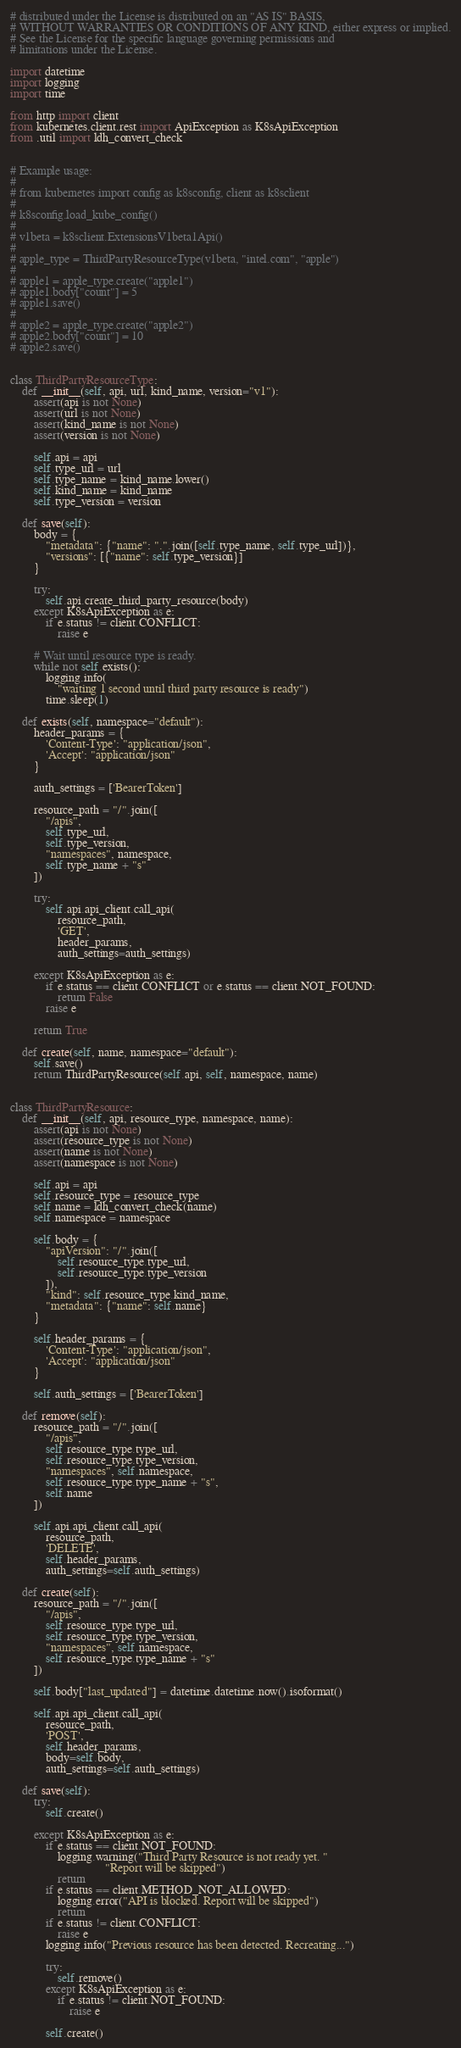Convert code to text. <code><loc_0><loc_0><loc_500><loc_500><_Python_># distributed under the License is distributed on an "AS IS" BASIS,
# WITHOUT WARRANTIES OR CONDITIONS OF ANY KIND, either express or implied.
# See the License for the specific language governing permissions and
# limitations under the License.

import datetime
import logging
import time

from http import client
from kubernetes.client.rest import ApiException as K8sApiException
from .util import ldh_convert_check


# Example usage:
#
# from kubernetes import config as k8sconfig, client as k8sclient
#
# k8sconfig.load_kube_config()
#
# v1beta = k8sclient.ExtensionsV1beta1Api()
#
# apple_type = ThirdPartyResourceType(v1beta, "intel.com", "apple")
#
# apple1 = apple_type.create("apple1")
# apple1.body["count"] = 5
# apple1.save()
#
# apple2 = apple_type.create("apple2")
# apple2.body["count"] = 10
# apple2.save()


class ThirdPartyResourceType:
    def __init__(self, api, url, kind_name, version="v1"):
        assert(api is not None)
        assert(url is not None)
        assert(kind_name is not None)
        assert(version is not None)

        self.api = api
        self.type_url = url
        self.type_name = kind_name.lower()
        self.kind_name = kind_name
        self.type_version = version

    def save(self):
        body = {
            "metadata": {"name": ".".join([self.type_name, self.type_url])},
            "versions": [{"name": self.type_version}]
        }

        try:
            self.api.create_third_party_resource(body)
        except K8sApiException as e:
            if e.status != client.CONFLICT:
                raise e

        # Wait until resource type is ready.
        while not self.exists():
            logging.info(
                "waiting 1 second until third party resource is ready")
            time.sleep(1)

    def exists(self, namespace="default"):
        header_params = {
            'Content-Type': "application/json",
            'Accept': "application/json"
        }

        auth_settings = ['BearerToken']

        resource_path = "/".join([
            "/apis",
            self.type_url,
            self.type_version,
            "namespaces", namespace,
            self.type_name + "s"
        ])

        try:
            self.api.api_client.call_api(
                resource_path,
                'GET',
                header_params,
                auth_settings=auth_settings)

        except K8sApiException as e:
            if e.status == client.CONFLICT or e.status == client.NOT_FOUND:
                return False
            raise e

        return True

    def create(self, name, namespace="default"):
        self.save()
        return ThirdPartyResource(self.api, self, namespace, name)


class ThirdPartyResource:
    def __init__(self, api, resource_type, namespace, name):
        assert(api is not None)
        assert(resource_type is not None)
        assert(name is not None)
        assert(namespace is not None)

        self.api = api
        self.resource_type = resource_type
        self.name = ldh_convert_check(name)
        self.namespace = namespace

        self.body = {
            "apiVersion": "/".join([
                self.resource_type.type_url,
                self.resource_type.type_version
            ]),
            "kind": self.resource_type.kind_name,
            "metadata": {"name": self.name}
        }

        self.header_params = {
            'Content-Type': "application/json",
            'Accept': "application/json"
        }

        self.auth_settings = ['BearerToken']

    def remove(self):
        resource_path = "/".join([
            "/apis",
            self.resource_type.type_url,
            self.resource_type.type_version,
            "namespaces", self.namespace,
            self.resource_type.type_name + "s",
            self.name
        ])

        self.api.api_client.call_api(
            resource_path,
            'DELETE',
            self.header_params,
            auth_settings=self.auth_settings)

    def create(self):
        resource_path = "/".join([
            "/apis",
            self.resource_type.type_url,
            self.resource_type.type_version,
            "namespaces", self.namespace,
            self.resource_type.type_name + "s"
        ])

        self.body["last_updated"] = datetime.datetime.now().isoformat()

        self.api.api_client.call_api(
            resource_path,
            'POST',
            self.header_params,
            body=self.body,
            auth_settings=self.auth_settings)

    def save(self):
        try:
            self.create()

        except K8sApiException as e:
            if e.status == client.NOT_FOUND:
                logging.warning("Third Party Resource is not ready yet. "
                                "Report will be skipped")
                return
            if e.status == client.METHOD_NOT_ALLOWED:
                logging.error("API is blocked. Report will be skipped")
                return
            if e.status != client.CONFLICT:
                raise e
            logging.info("Previous resource has been detected. Recreating...")

            try:
                self.remove()
            except K8sApiException as e:
                if e.status != client.NOT_FOUND:
                    raise e

            self.create()
</code> 